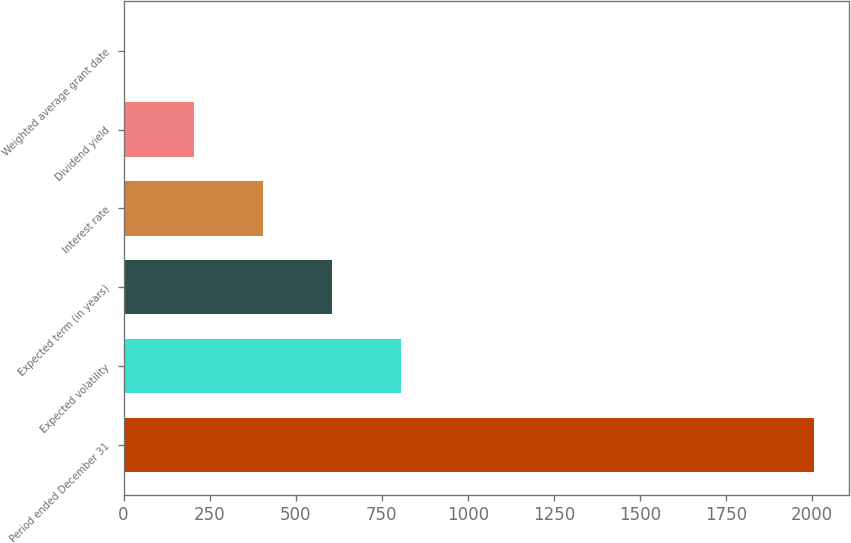<chart> <loc_0><loc_0><loc_500><loc_500><bar_chart><fcel>Period ended December 31<fcel>Expected volatility<fcel>Expected term (in years)<fcel>Interest rate<fcel>Dividend yield<fcel>Weighted average grant date<nl><fcel>2006<fcel>804.88<fcel>604.7<fcel>404.52<fcel>204.34<fcel>4.15<nl></chart> 